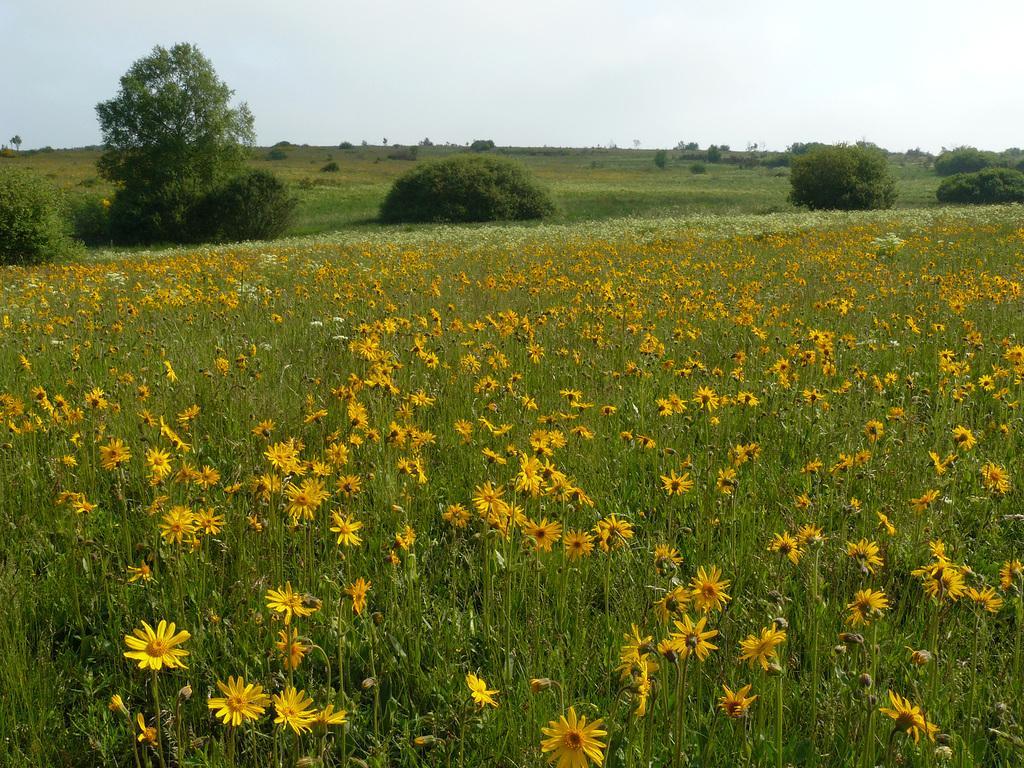Please provide a concise description of this image. In this image we can see flowers, plants. In the background of the image there are trees, sky. 